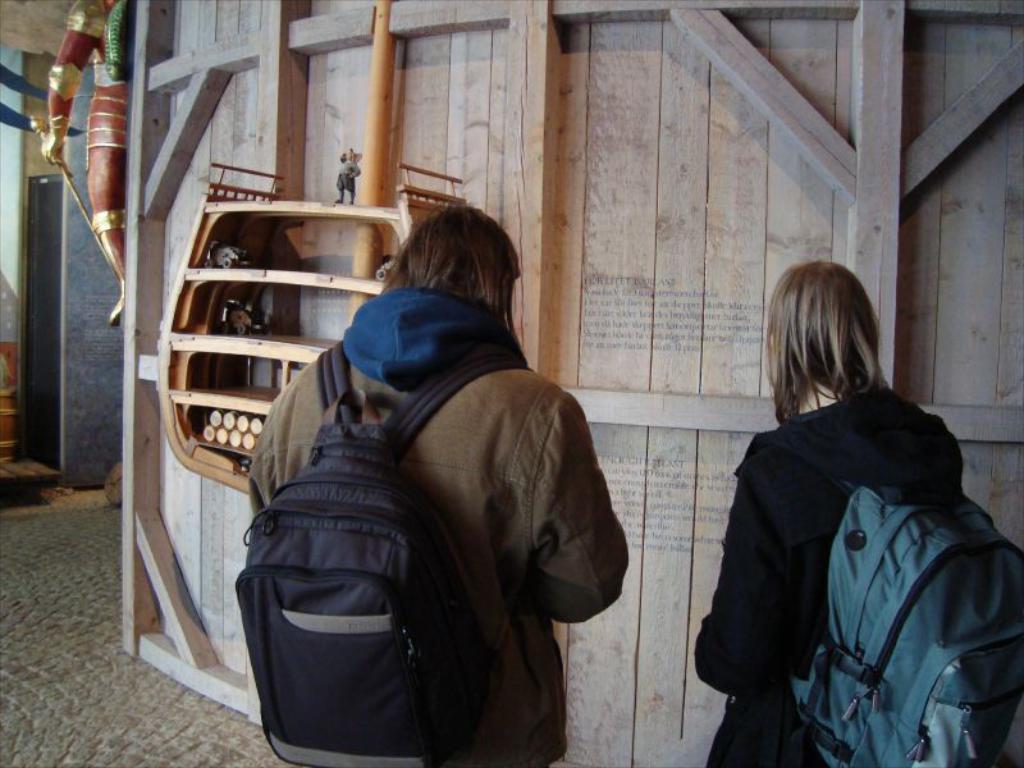Please provide a concise description of this image. In this picture we can see persons wore jackets carrying their bags and they are standing and in front of them we have wooden wall, pole, racks, some statue, box. 